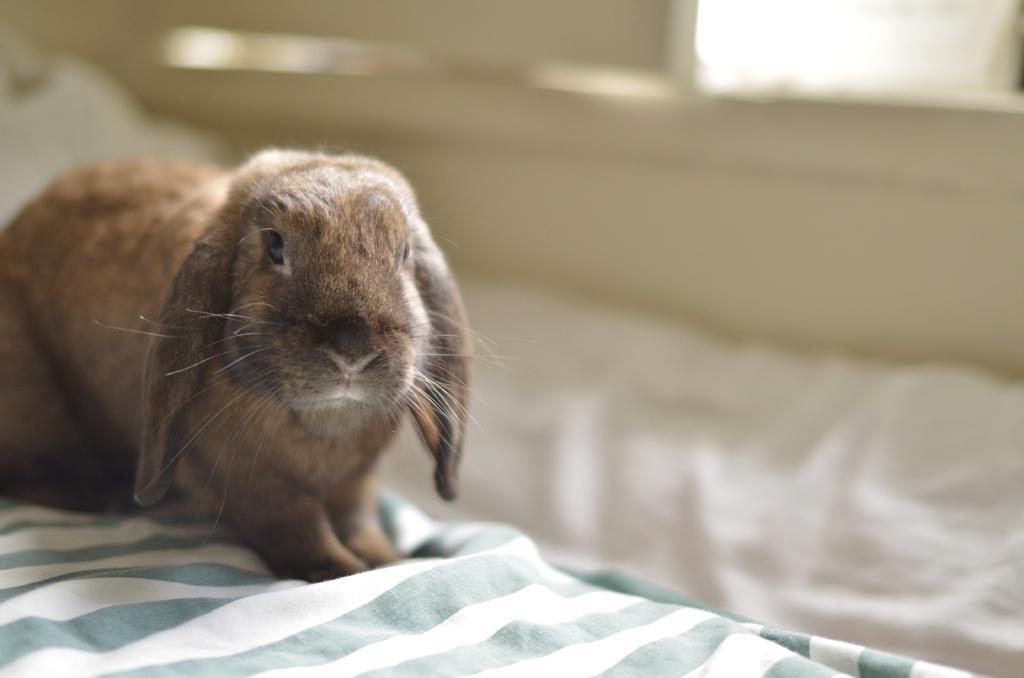In one or two sentences, can you explain what this image depicts? In the image there is a brown rabbit sitting on a bed sheet and the background of the rabbit is blur. 